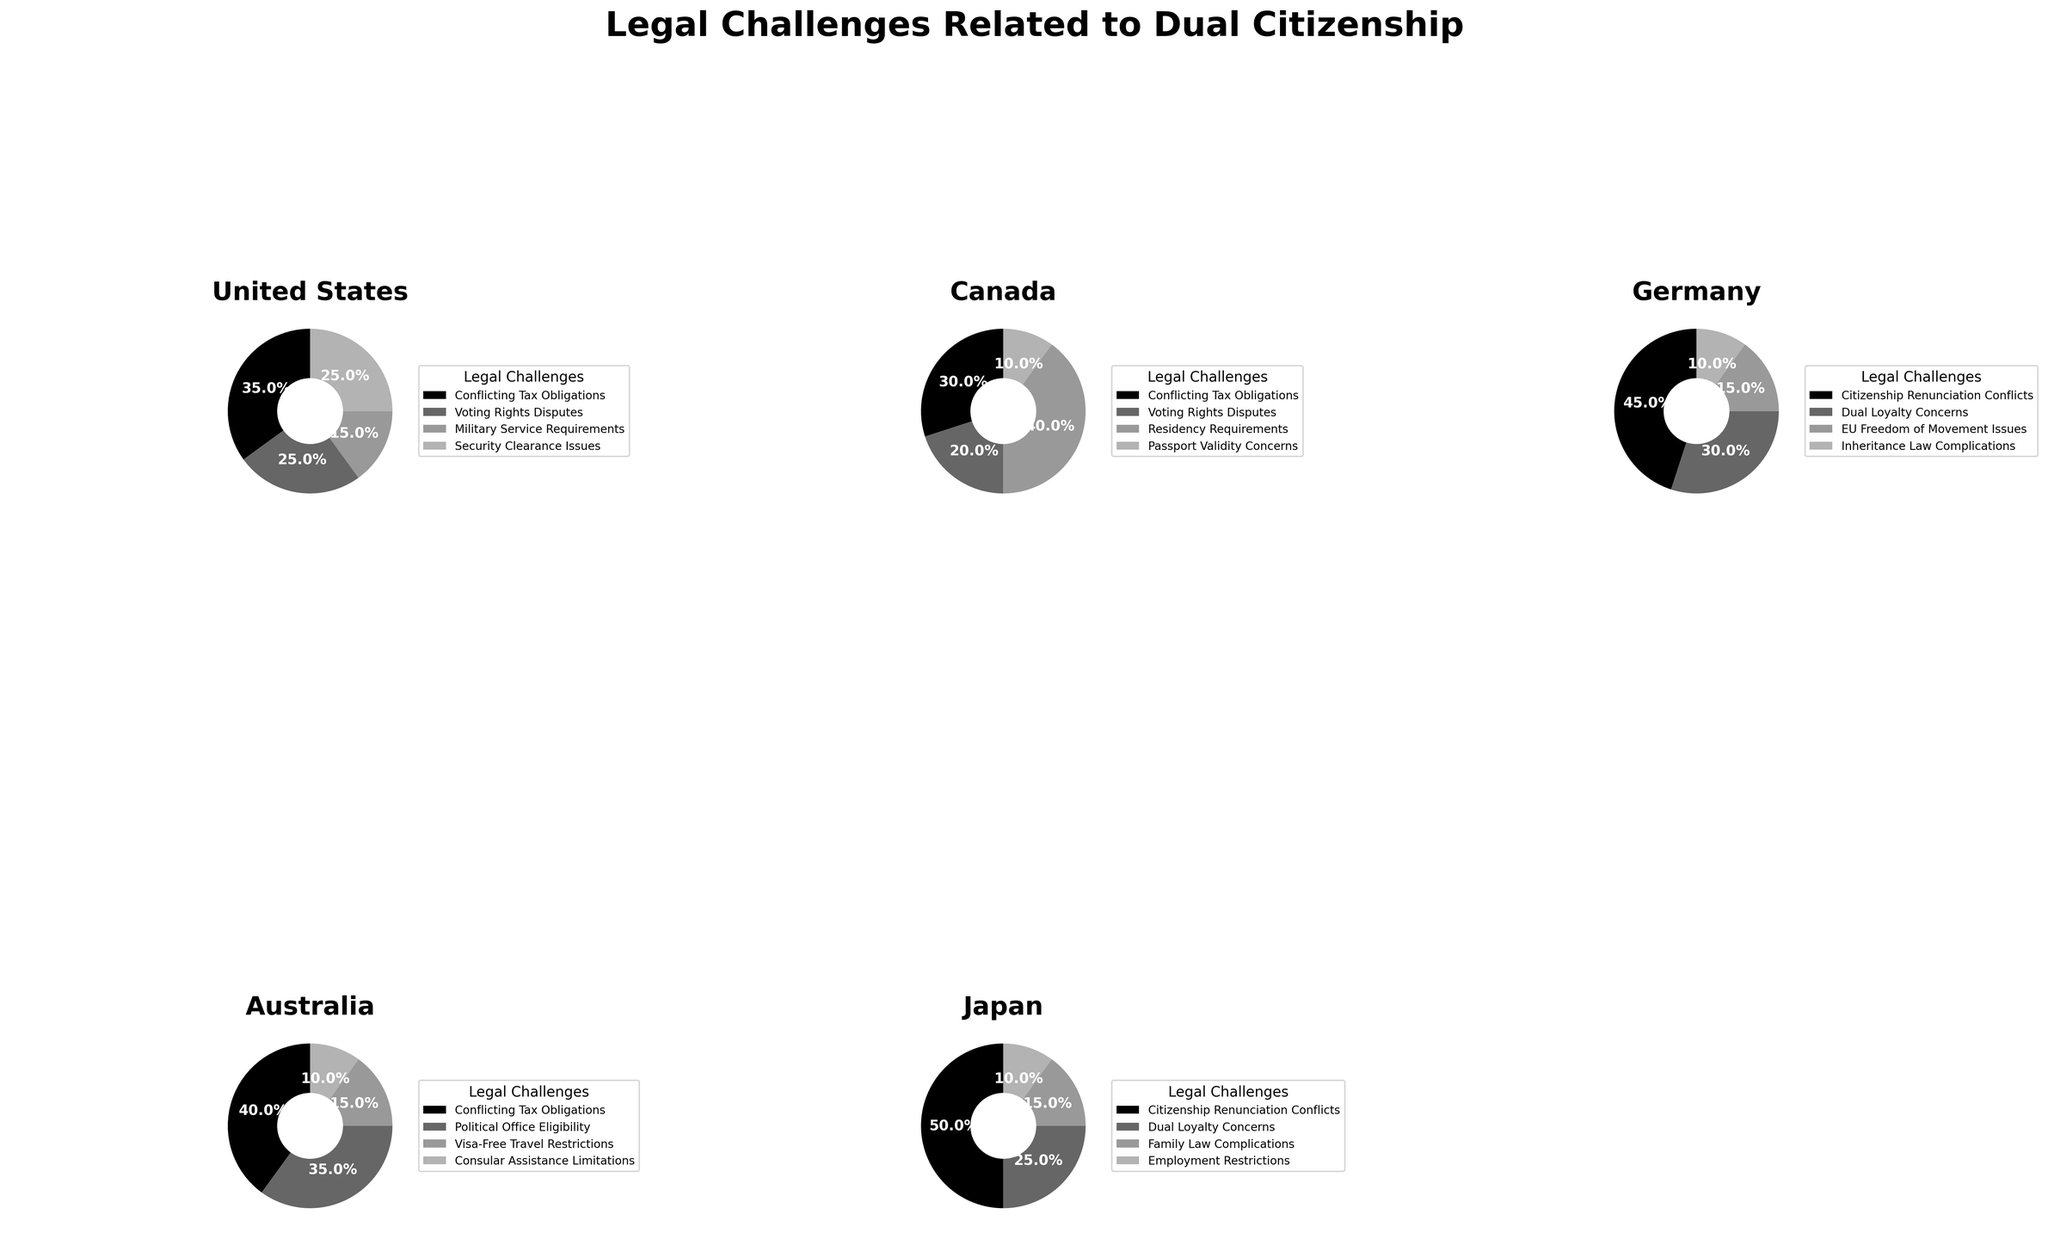What's the largest legal challenge in Germany related to dual citizenship? The largest segment for Germany in the pie chart represents 'Citizenship Renunciation Conflicts' with 45% of cases.
Answer: Citizenship Renunciation Conflicts Which country has the highest percentage of cases involving conflicting tax obligations? By comparing the segments across pie charts, Australia has the highest percentage for 'Conflicting Tax Obligations' with 40%.
Answer: Australia How do the security clearance issues in the United States compare to the passport validity concerns in Canada? The United States has 25% of cases related to 'Security Clearance Issues' while Canada has 10% related to 'Passport Validity Concerns'. The percentage is higher in the United States.
Answer: Security Clearance Issues are higher What is the average percentage of cases involving dual loyalty concerns in Germany and Japan? Germany has 30% and Japan has 25% for 'Dual Loyalty Concerns'. The sum is 55%, and the average is 55/2 = 27.5%.
Answer: 27.5% Which legal challenge related to dual citizenship appears most frequently across all the countries? Checking each country’s segments, 'Conflicting Tax Obligations' appear in the United States, Canada, and Australia. None of the other challenges are as frequent across different countries.
Answer: Conflicting Tax Obligations Which country deals the most with voting rights disputes according to the chart? Referring to the pie charts, the United States has 25% and Canada has 20% for 'Voting Rights Disputes', making the United States the country with more cases.
Answer: United States Between Canada and Germany, which country has a greater percentage of cases involving residency or movement issues? In Canada, 'Residency Requirements' have 40%. In Germany, 'EU Freedom of Movement Issues' have 15%. Canada has a greater percentage.
Answer: Canada What percentage of legal challenges in Australia are related to political office eligibility, compared to other challenges in the same country? Australia’s pie chart shows 35% for 'Political Office Eligibility' with other challenges having 40%, 15%, and 10%. Thus, 'Political Office Eligibility' is the second largest.
Answer: Second largest (35%) What is the smallest legal challenge in Japan and its percentage? For Japan, the smallest segment represents 'Employment Restrictions' at 10%.
Answer: Employment Restrictions, 10% 